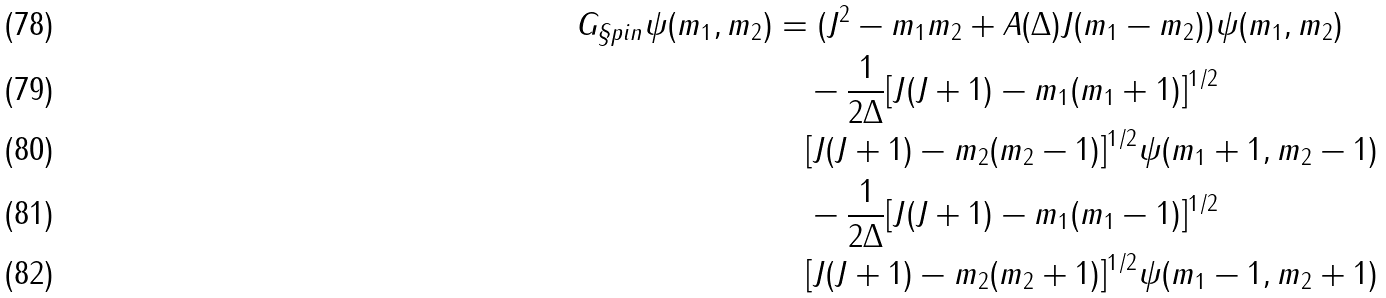Convert formula to latex. <formula><loc_0><loc_0><loc_500><loc_500>G _ { \S p i n } \psi ( m _ { 1 } , m _ { 2 } ) & = ( J ^ { 2 } - m _ { 1 } m _ { 2 } + A ( \Delta ) J ( m _ { 1 } - m _ { 2 } ) ) \psi ( m _ { 1 } , m _ { 2 } ) \\ & \quad - \frac { 1 } { 2 \Delta } [ J ( J + 1 ) - m _ { 1 } ( m _ { 1 } + 1 ) ] ^ { 1 / 2 } \\ & \quad [ J ( J + 1 ) - m _ { 2 } ( m _ { 2 } - 1 ) ] ^ { 1 / 2 } \psi ( m _ { 1 } + 1 , m _ { 2 } - 1 ) \\ & \quad - \frac { 1 } { 2 \Delta } [ J ( J + 1 ) - m _ { 1 } ( m _ { 1 } - 1 ) ] ^ { 1 / 2 } \\ & \quad [ J ( J + 1 ) - m _ { 2 } ( m _ { 2 } + 1 ) ] ^ { 1 / 2 } \psi ( m _ { 1 } - 1 , m _ { 2 } + 1 )</formula> 